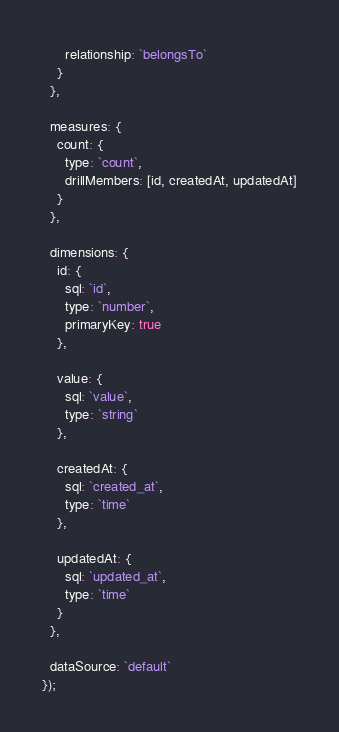<code> <loc_0><loc_0><loc_500><loc_500><_JavaScript_>      relationship: `belongsTo`
    }
  },
  
  measures: {
    count: {
      type: `count`,
      drillMembers: [id, createdAt, updatedAt]
    }
  },
  
  dimensions: {
    id: {
      sql: `id`,
      type: `number`,
      primaryKey: true
    },
    
    value: {
      sql: `value`,
      type: `string`
    },
    
    createdAt: {
      sql: `created_at`,
      type: `time`
    },
    
    updatedAt: {
      sql: `updated_at`,
      type: `time`
    }
  },
  
  dataSource: `default`
});
</code> 